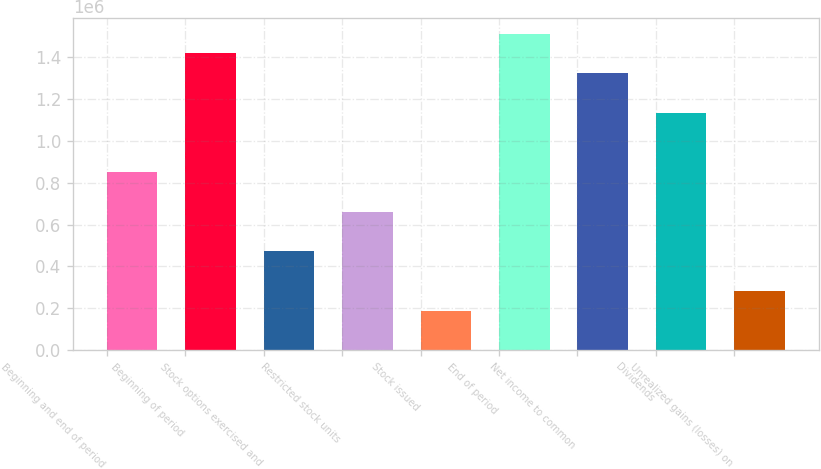<chart> <loc_0><loc_0><loc_500><loc_500><bar_chart><fcel>Beginning and end of period<fcel>Beginning of period<fcel>Stock options exercised and<fcel>Restricted stock units<fcel>Stock issued<fcel>End of period<fcel>Net income to common<fcel>Dividends<fcel>Unrealized gains (losses) on<nl><fcel>850654<fcel>1.41772e+06<fcel>472608<fcel>661632<fcel>189074<fcel>1.51224e+06<fcel>1.32321e+06<fcel>1.13419e+06<fcel>283586<nl></chart> 